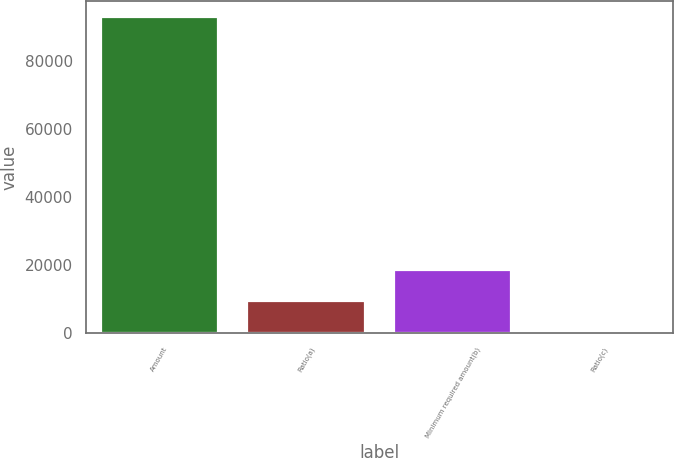Convert chart. <chart><loc_0><loc_0><loc_500><loc_500><bar_chart><fcel>Amount<fcel>Ratio(a)<fcel>Minimum required amount(b)<fcel>Ratio(c)<nl><fcel>93024<fcel>9316.91<fcel>18617.7<fcel>16.12<nl></chart> 